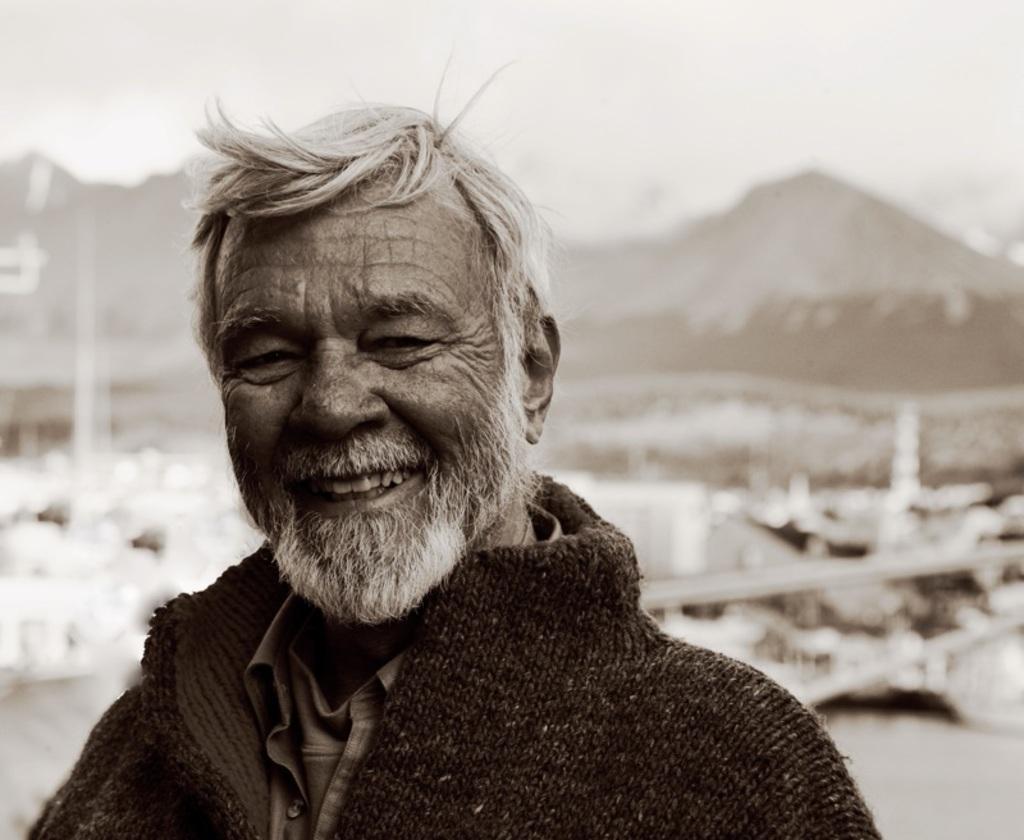Please provide a concise description of this image. In this image we can see a person. In the background of the image there is a blur background. 